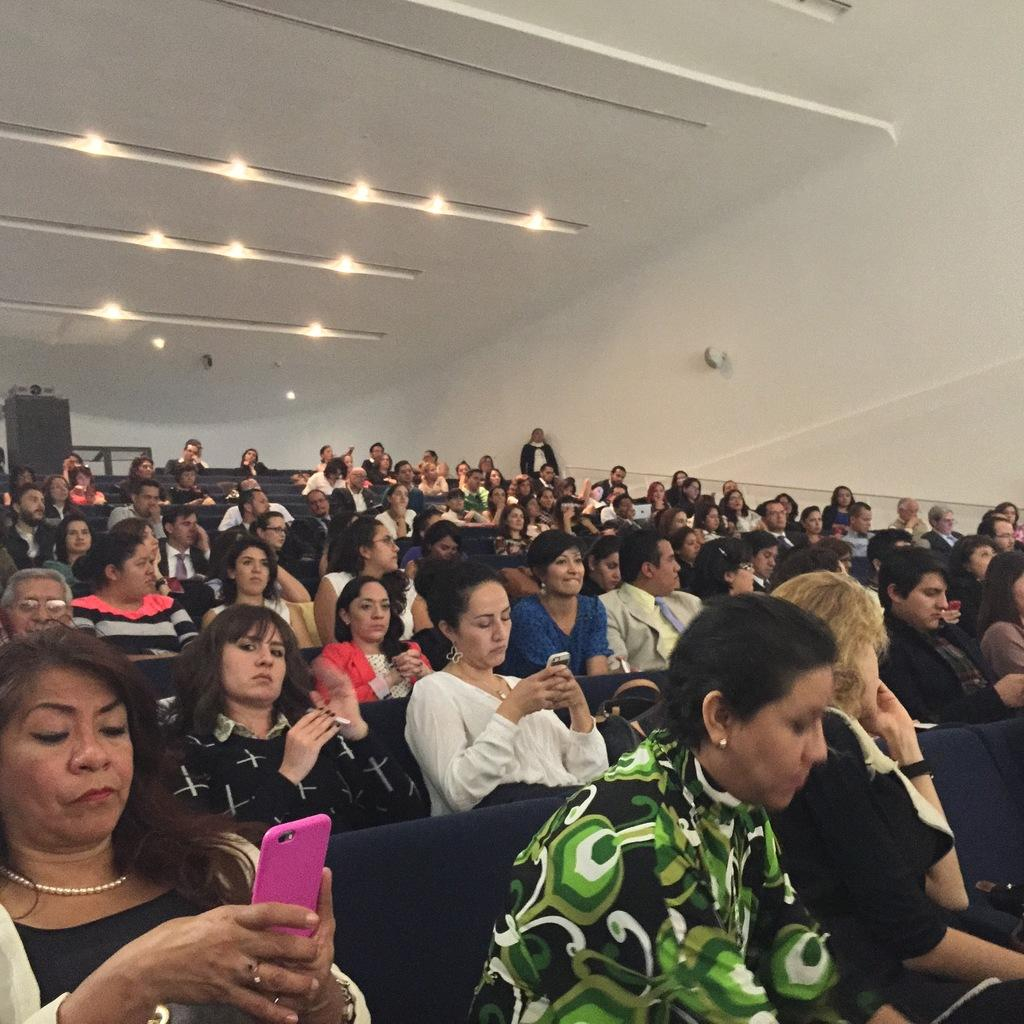How many people are present in the room in the image? There are many people sitting in the room in the image. What can be seen in the ceiling of the room? There are lights in the ceiling in the image. What is a lady doing in the bottom left of the image? A lady is using a phone in the bottom left of the image. What type of fiction is the lady reading on her phone in the image? There is no indication in the image that the lady is reading fiction on her phone. 